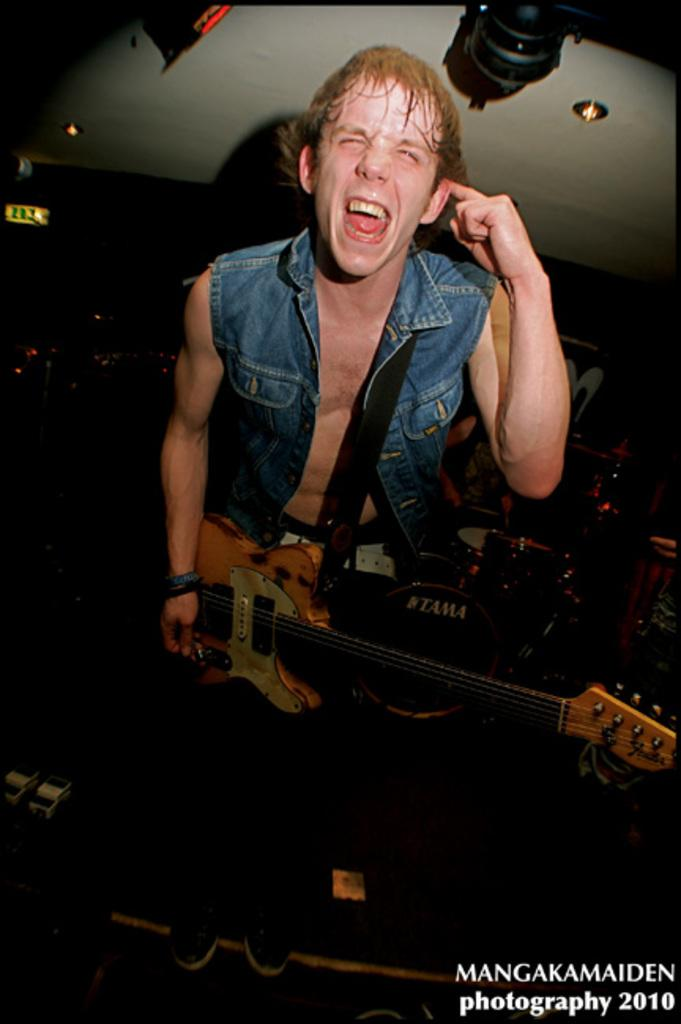What is the man in the image doing? The man is singing. What object is the man holding in the image? The man is holding a guitar. What is the man standing in front of in the image? The man is in front of a microphone. Can you tell me how many visitors are present at the zoo in the image? There is no zoo or visitors present in the image; it features a man singing with a guitar and a microphone. Is the man in the image asking for help while singing? There is no indication in the image that the man is asking for help while singing. 